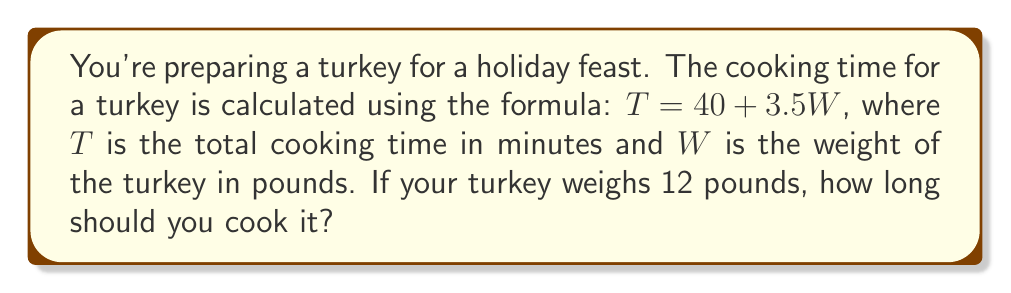Help me with this question. Let's solve this step-by-step:

1) We are given the formula: $T = 40 + 3.5W$
   Where $T$ is the total cooking time in minutes and $W$ is the weight in pounds.

2) We know the turkey weighs 12 pounds, so $W = 12$.

3) Let's substitute this into our formula:
   $T = 40 + 3.5(12)$

4) Now, let's solve the equation:
   $T = 40 + 42$
   $T = 82$

5) Therefore, the total cooking time $T$ is 82 minutes.
Answer: 82 minutes 